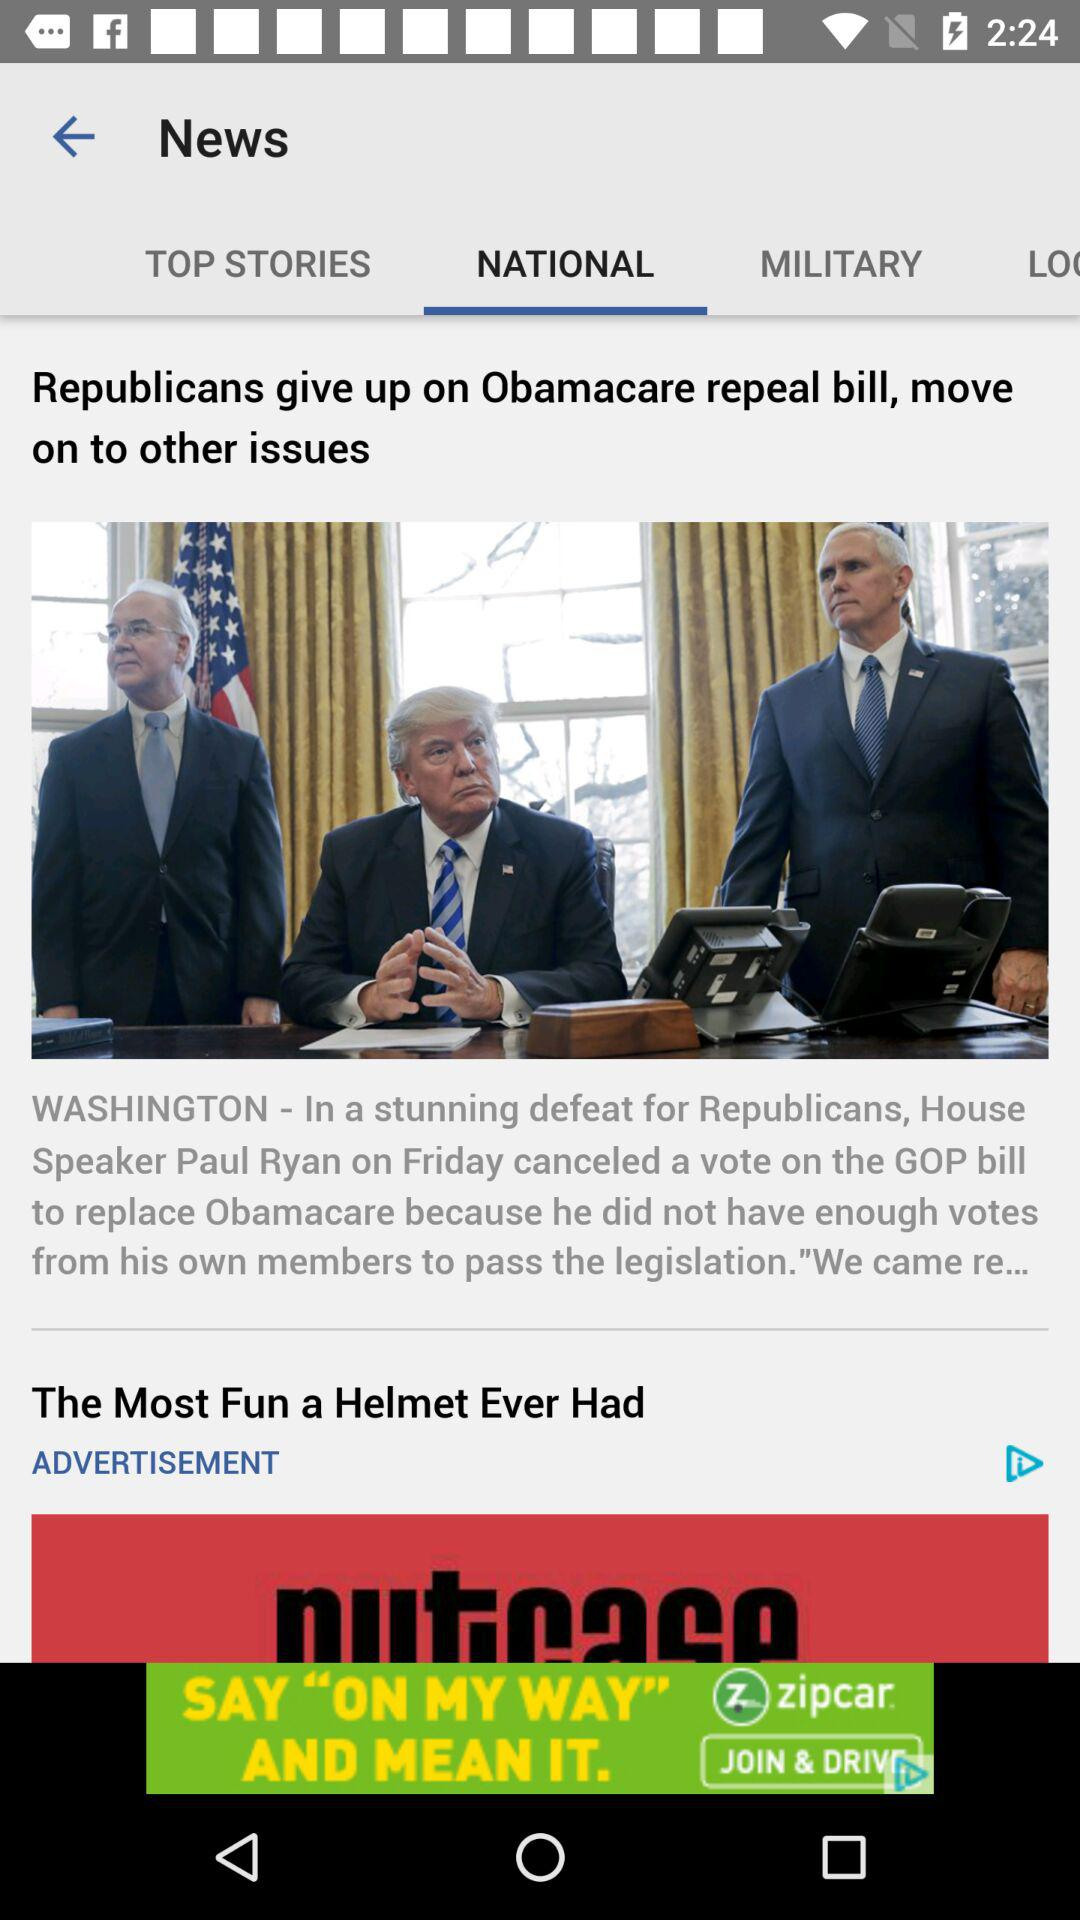Which tab am I on? You are on the "NATIONAL" tab. 